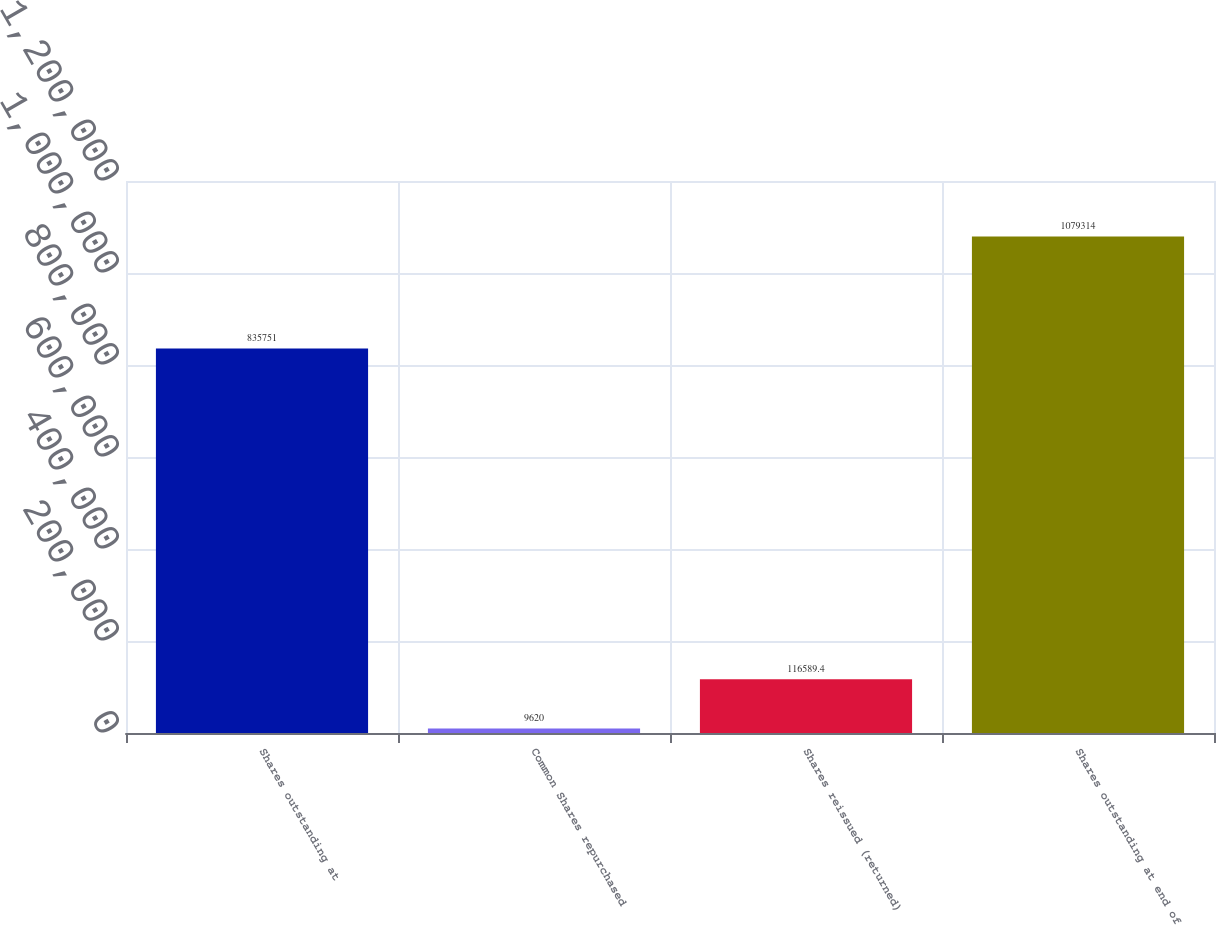<chart> <loc_0><loc_0><loc_500><loc_500><bar_chart><fcel>Shares outstanding at<fcel>Common Shares repurchased<fcel>Shares reissued (returned)<fcel>Shares outstanding at end of<nl><fcel>835751<fcel>9620<fcel>116589<fcel>1.07931e+06<nl></chart> 